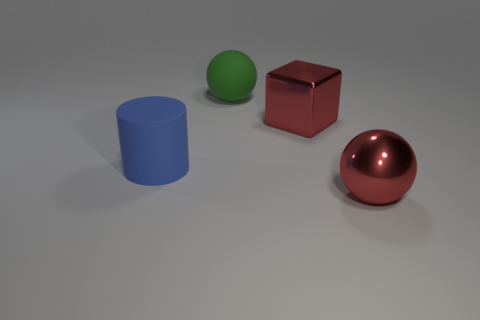What textures are visible on the objects in the image? The objects in the image exhibit smooth textures with a matte finish on the blue cylinder and the green sphere, while the red block and red sphere have reflective metallic surfaces that add visual interest to their appearance. 